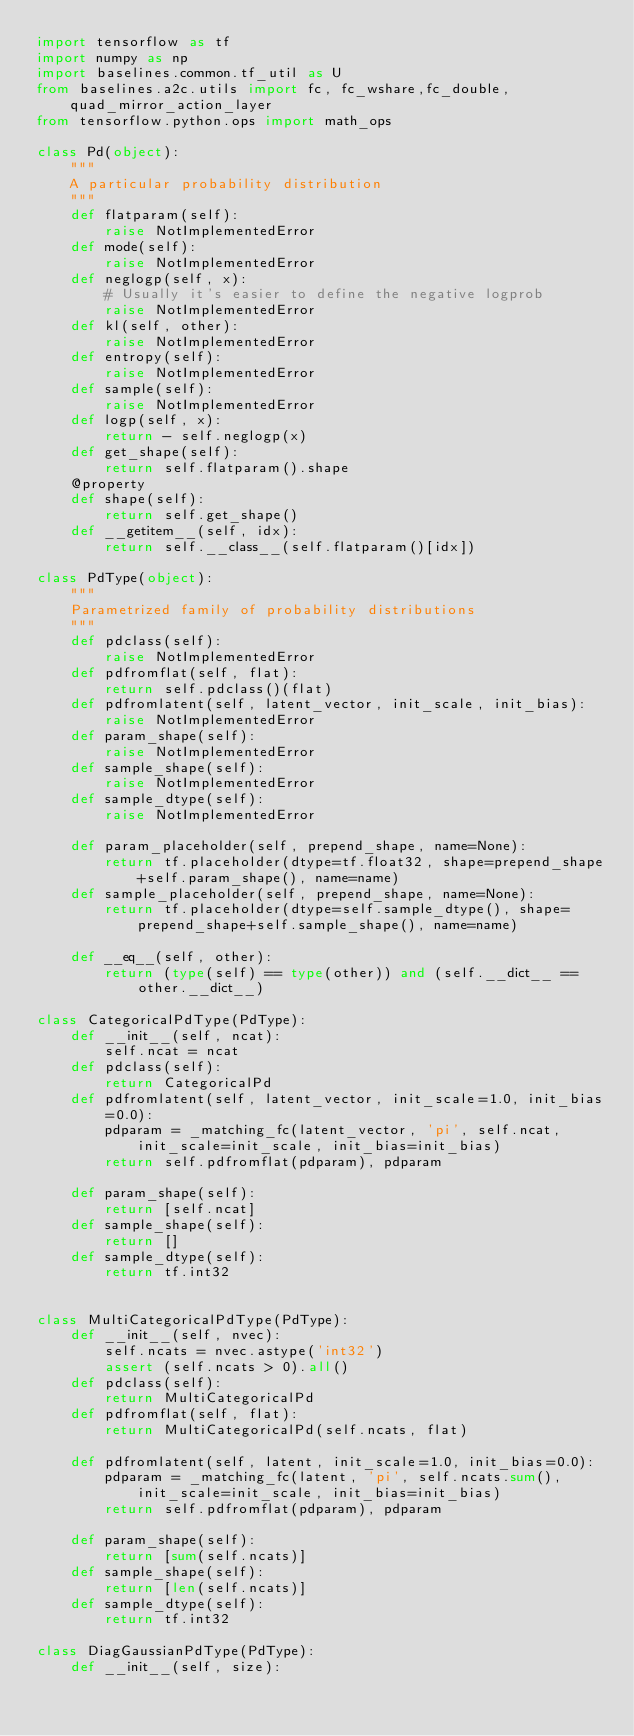Convert code to text. <code><loc_0><loc_0><loc_500><loc_500><_Python_>import tensorflow as tf
import numpy as np
import baselines.common.tf_util as U
from baselines.a2c.utils import fc, fc_wshare,fc_double, quad_mirror_action_layer
from tensorflow.python.ops import math_ops

class Pd(object):
    """
    A particular probability distribution
    """
    def flatparam(self):
        raise NotImplementedError
    def mode(self):
        raise NotImplementedError
    def neglogp(self, x):
        # Usually it's easier to define the negative logprob
        raise NotImplementedError
    def kl(self, other):
        raise NotImplementedError
    def entropy(self):
        raise NotImplementedError
    def sample(self):
        raise NotImplementedError
    def logp(self, x):
        return - self.neglogp(x)
    def get_shape(self):
        return self.flatparam().shape
    @property
    def shape(self):
        return self.get_shape()
    def __getitem__(self, idx):
        return self.__class__(self.flatparam()[idx])

class PdType(object):
    """
    Parametrized family of probability distributions
    """
    def pdclass(self):
        raise NotImplementedError
    def pdfromflat(self, flat):
        return self.pdclass()(flat)
    def pdfromlatent(self, latent_vector, init_scale, init_bias):
        raise NotImplementedError
    def param_shape(self):
        raise NotImplementedError
    def sample_shape(self):
        raise NotImplementedError
    def sample_dtype(self):
        raise NotImplementedError

    def param_placeholder(self, prepend_shape, name=None):
        return tf.placeholder(dtype=tf.float32, shape=prepend_shape+self.param_shape(), name=name)
    def sample_placeholder(self, prepend_shape, name=None):
        return tf.placeholder(dtype=self.sample_dtype(), shape=prepend_shape+self.sample_shape(), name=name)

    def __eq__(self, other):
        return (type(self) == type(other)) and (self.__dict__ == other.__dict__)

class CategoricalPdType(PdType):
    def __init__(self, ncat):
        self.ncat = ncat
    def pdclass(self):
        return CategoricalPd
    def pdfromlatent(self, latent_vector, init_scale=1.0, init_bias=0.0):
        pdparam = _matching_fc(latent_vector, 'pi', self.ncat, init_scale=init_scale, init_bias=init_bias)
        return self.pdfromflat(pdparam), pdparam

    def param_shape(self):
        return [self.ncat]
    def sample_shape(self):
        return []
    def sample_dtype(self):
        return tf.int32


class MultiCategoricalPdType(PdType):
    def __init__(self, nvec):
        self.ncats = nvec.astype('int32')
        assert (self.ncats > 0).all()
    def pdclass(self):
        return MultiCategoricalPd
    def pdfromflat(self, flat):
        return MultiCategoricalPd(self.ncats, flat)

    def pdfromlatent(self, latent, init_scale=1.0, init_bias=0.0):
        pdparam = _matching_fc(latent, 'pi', self.ncats.sum(), init_scale=init_scale, init_bias=init_bias)
        return self.pdfromflat(pdparam), pdparam

    def param_shape(self):
        return [sum(self.ncats)]
    def sample_shape(self):
        return [len(self.ncats)]
    def sample_dtype(self):
        return tf.int32

class DiagGaussianPdType(PdType):
    def __init__(self, size):</code> 